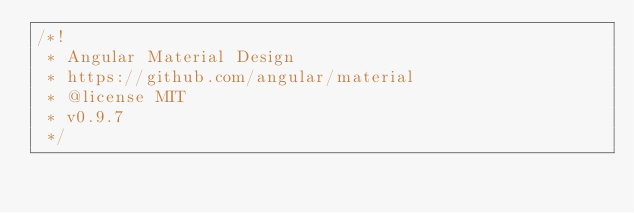<code> <loc_0><loc_0><loc_500><loc_500><_JavaScript_>/*!
 * Angular Material Design
 * https://github.com/angular/material
 * @license MIT
 * v0.9.7
 */</code> 